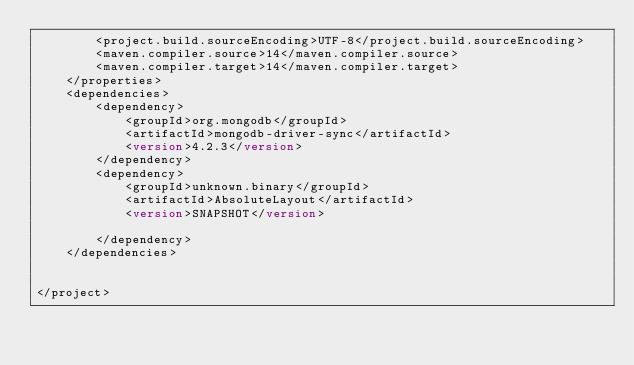<code> <loc_0><loc_0><loc_500><loc_500><_XML_>        <project.build.sourceEncoding>UTF-8</project.build.sourceEncoding>
        <maven.compiler.source>14</maven.compiler.source>
        <maven.compiler.target>14</maven.compiler.target>
    </properties>
    <dependencies>
        <dependency>
            <groupId>org.mongodb</groupId>
            <artifactId>mongodb-driver-sync</artifactId>
            <version>4.2.3</version>
        </dependency>
        <dependency>
            <groupId>unknown.binary</groupId>
            <artifactId>AbsoluteLayout</artifactId>
            <version>SNAPSHOT</version>
            
        </dependency>
    </dependencies>
    
  
</project></code> 